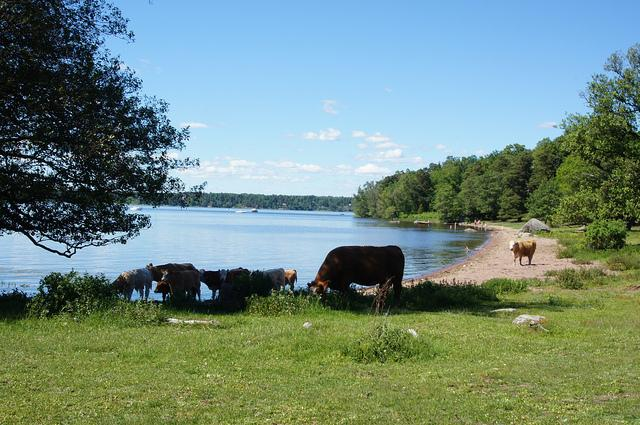How many animal species are shown NOT including the people on shore? one 